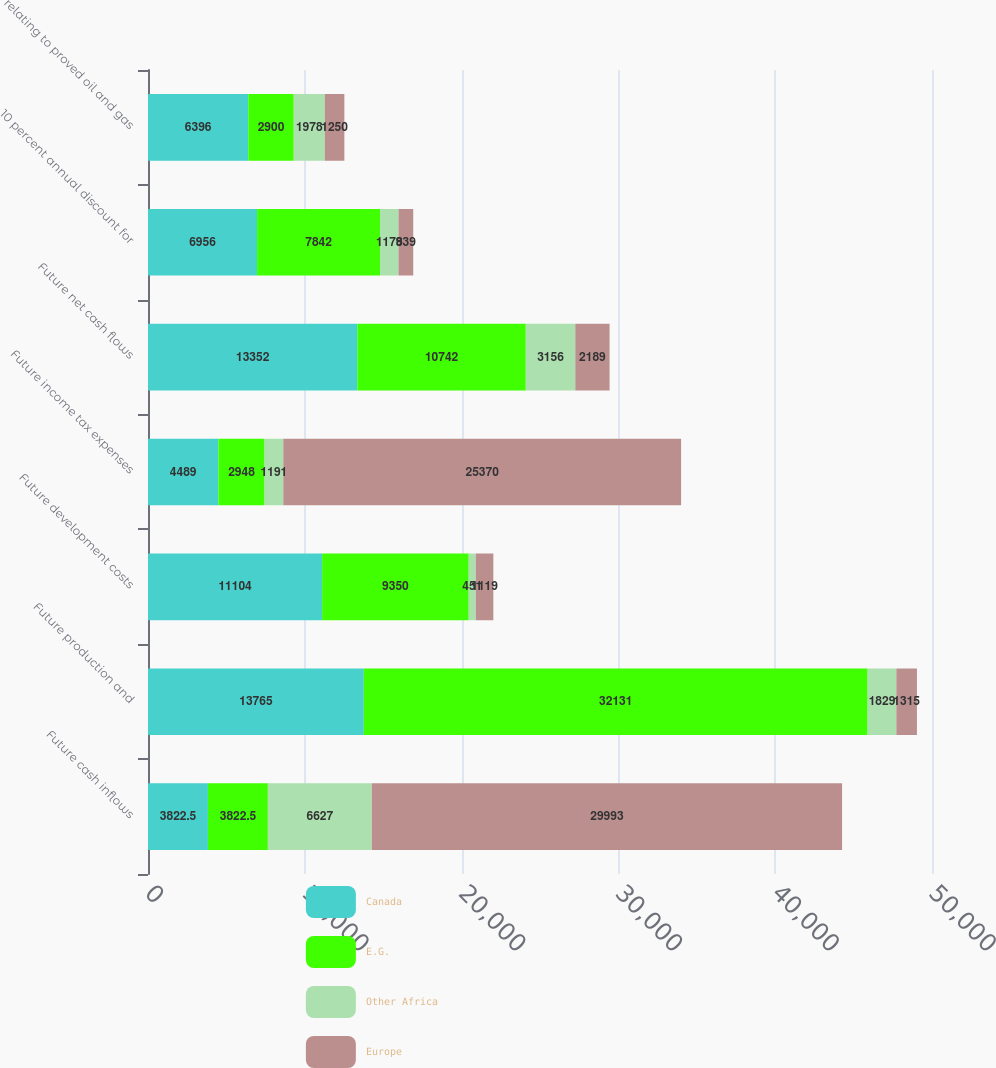Convert chart to OTSL. <chart><loc_0><loc_0><loc_500><loc_500><stacked_bar_chart><ecel><fcel>Future cash inflows<fcel>Future production and<fcel>Future development costs<fcel>Future income tax expenses<fcel>Future net cash flows<fcel>10 percent annual discount for<fcel>relating to proved oil and gas<nl><fcel>Canada<fcel>3822.5<fcel>13765<fcel>11104<fcel>4489<fcel>13352<fcel>6956<fcel>6396<nl><fcel>E.G.<fcel>3822.5<fcel>32131<fcel>9350<fcel>2948<fcel>10742<fcel>7842<fcel>2900<nl><fcel>Other Africa<fcel>6627<fcel>1829<fcel>451<fcel>1191<fcel>3156<fcel>1178<fcel>1978<nl><fcel>Europe<fcel>29993<fcel>1315<fcel>1119<fcel>25370<fcel>2189<fcel>939<fcel>1250<nl></chart> 